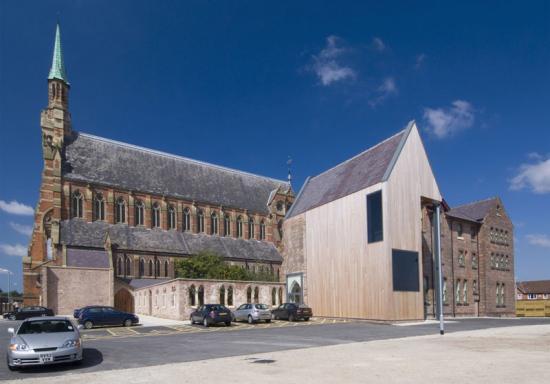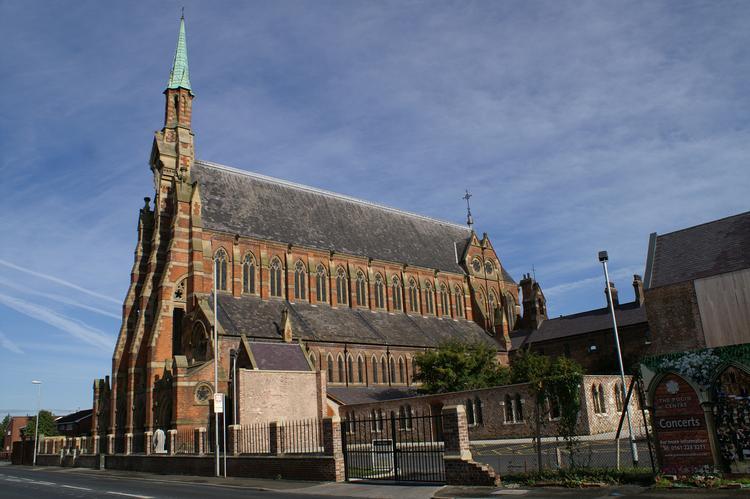The first image is the image on the left, the second image is the image on the right. For the images shown, is this caption "There is no visible grass in at least one image." true? Answer yes or no. Yes. 